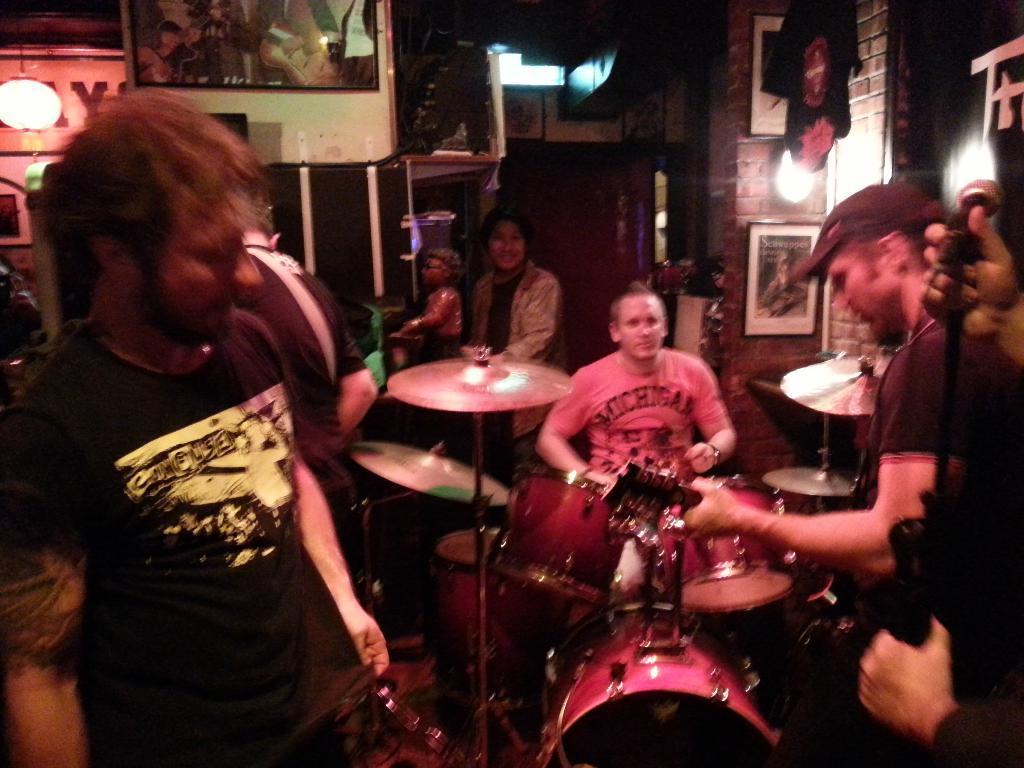Describe this image in one or two sentences. There are group of people playing musical instruments. To the left corner there is man with black t-shirt. And to the right corner there is a man is playing guitar. And in the middle there is a man with pink t-shirt is playing the drums. In the background there are some frames. And to the left corner there is a lamp. And to the right corner there is a pillars, light. 